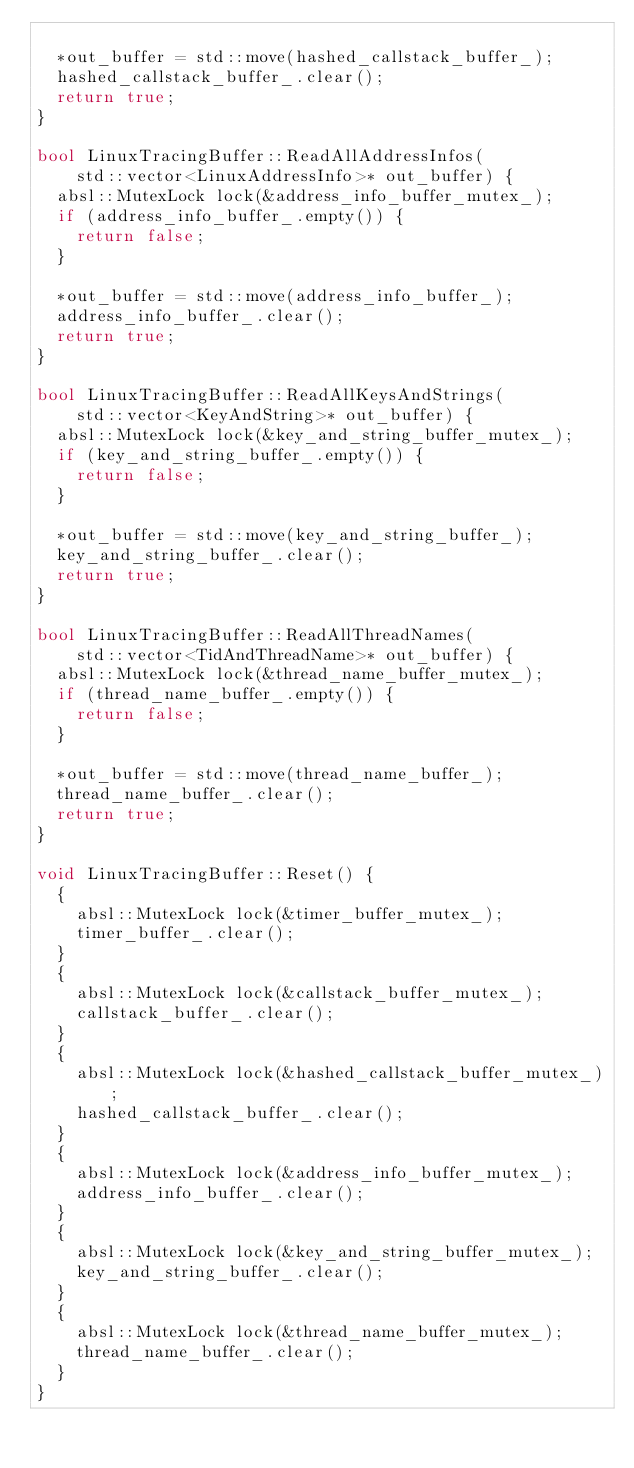Convert code to text. <code><loc_0><loc_0><loc_500><loc_500><_C++_>
  *out_buffer = std::move(hashed_callstack_buffer_);
  hashed_callstack_buffer_.clear();
  return true;
}

bool LinuxTracingBuffer::ReadAllAddressInfos(
    std::vector<LinuxAddressInfo>* out_buffer) {
  absl::MutexLock lock(&address_info_buffer_mutex_);
  if (address_info_buffer_.empty()) {
    return false;
  }

  *out_buffer = std::move(address_info_buffer_);
  address_info_buffer_.clear();
  return true;
}

bool LinuxTracingBuffer::ReadAllKeysAndStrings(
    std::vector<KeyAndString>* out_buffer) {
  absl::MutexLock lock(&key_and_string_buffer_mutex_);
  if (key_and_string_buffer_.empty()) {
    return false;
  }

  *out_buffer = std::move(key_and_string_buffer_);
  key_and_string_buffer_.clear();
  return true;
}

bool LinuxTracingBuffer::ReadAllThreadNames(
    std::vector<TidAndThreadName>* out_buffer) {
  absl::MutexLock lock(&thread_name_buffer_mutex_);
  if (thread_name_buffer_.empty()) {
    return false;
  }

  *out_buffer = std::move(thread_name_buffer_);
  thread_name_buffer_.clear();
  return true;
}

void LinuxTracingBuffer::Reset() {
  {
    absl::MutexLock lock(&timer_buffer_mutex_);
    timer_buffer_.clear();
  }
  {
    absl::MutexLock lock(&callstack_buffer_mutex_);
    callstack_buffer_.clear();
  }
  {
    absl::MutexLock lock(&hashed_callstack_buffer_mutex_);
    hashed_callstack_buffer_.clear();
  }
  {
    absl::MutexLock lock(&address_info_buffer_mutex_);
    address_info_buffer_.clear();
  }
  {
    absl::MutexLock lock(&key_and_string_buffer_mutex_);
    key_and_string_buffer_.clear();
  }
  {
    absl::MutexLock lock(&thread_name_buffer_mutex_);
    thread_name_buffer_.clear();
  }
}
</code> 